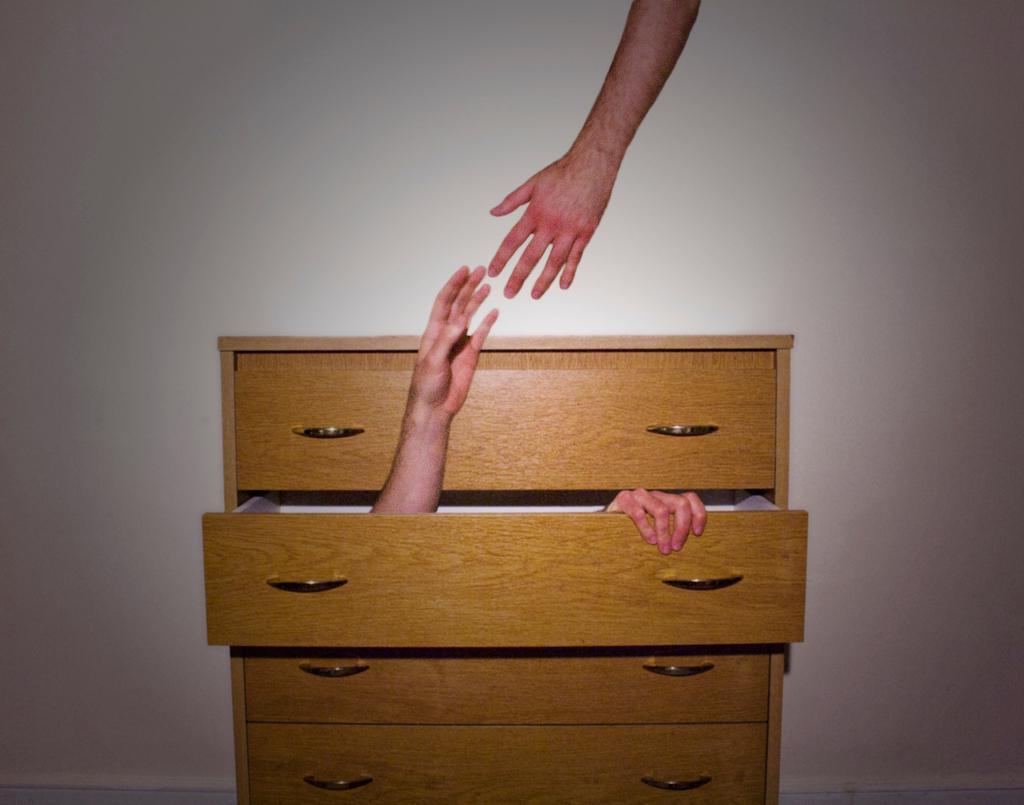Can you describe this image briefly? At the bottom of this image, there are wooden desks. In one of the desks, there are two hands. One of these hands is stretched up. At the top of this image, there is a hand of a person is stretched down. And the background of this image is white in color. 